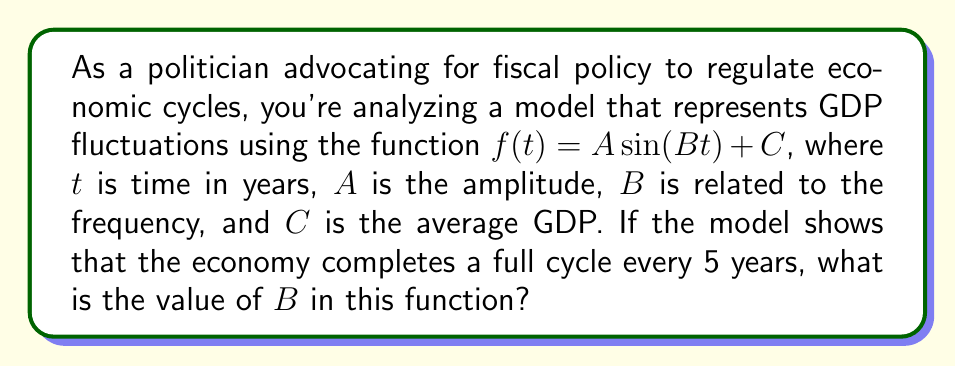Could you help me with this problem? To solve this problem, we need to understand the relationship between the period of a sine function and its frequency. Let's approach this step-by-step:

1) The general form of a sine function is:
   $f(t) = A \sin(Bt) + C$

2) In trigonometry, the period of a sine function is given by the formula:
   $\text{Period} = \frac{2\pi}{|B|}$

3) We're told that the economy completes a full cycle every 5 years. This means the period is 5 years:
   $\text{Period} = 5$

4) Now we can set up an equation:
   $5 = \frac{2\pi}{|B|}$

5) To solve for $B$, first multiply both sides by $|B|$:
   $5|B| = 2\pi$

6) Then divide both sides by 5:
   $|B| = \frac{2\pi}{5}$

7) Since we're dealing with a period (which is always positive), we can assume $B$ is positive and remove the absolute value signs:
   $B = \frac{2\pi}{5}$

8) This can be simplified to:
   $B = \frac{2\pi}{5} \approx 1.2566$

Therefore, the value of $B$ in the function is $\frac{2\pi}{5}$ or approximately 1.2566 radians per year.
Answer: $B = \frac{2\pi}{5}$ 